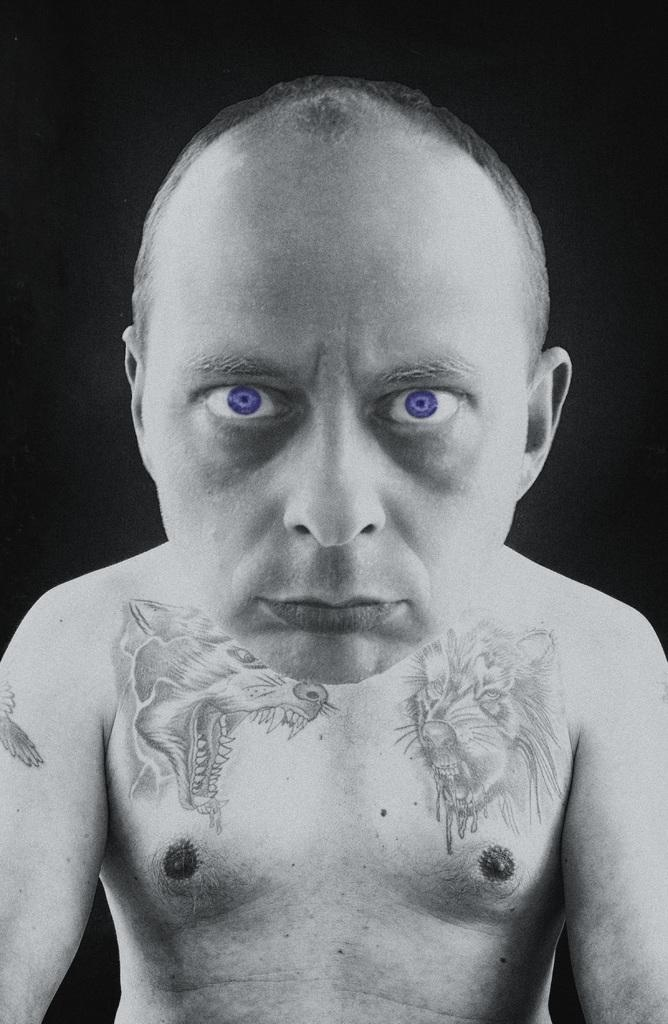What is present in the image? There is a person in the image. Can you describe the person's appearance? The person has tattoos on their body. What type of mist can be seen surrounding the person in the image? There is no mist present in the image; it only features a person with tattoos. 